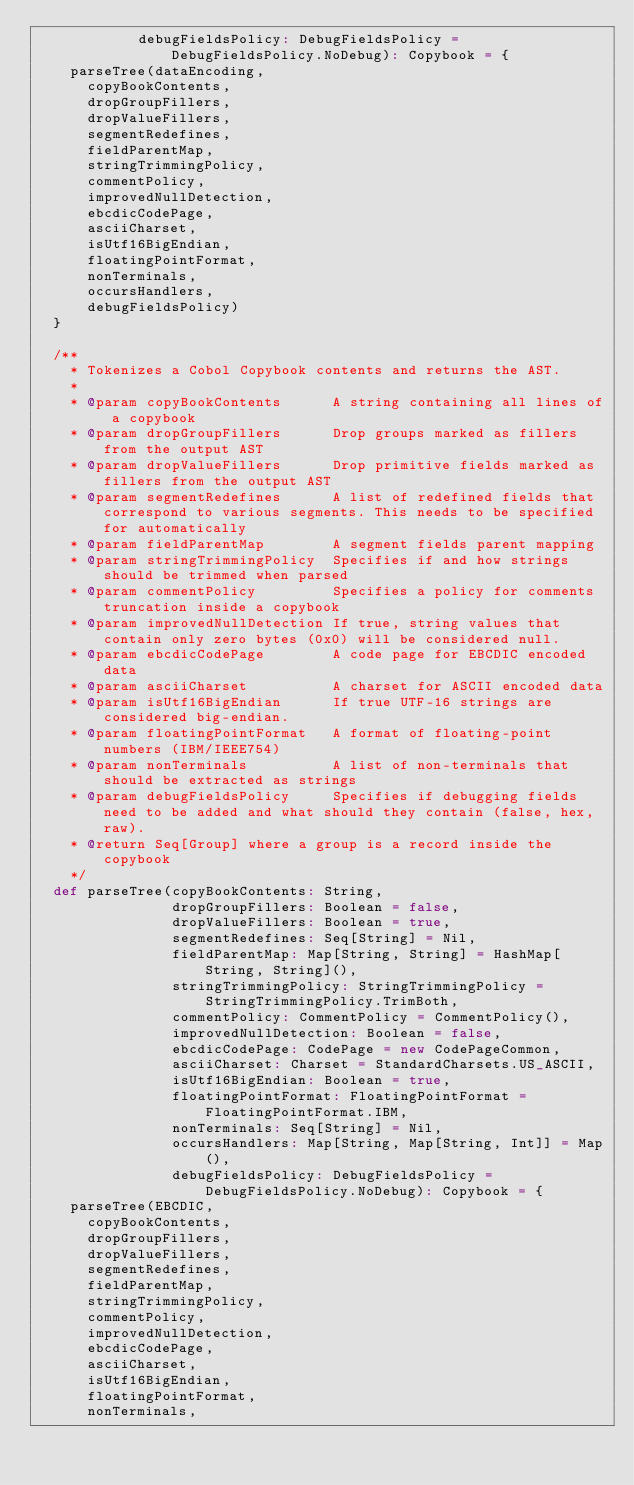<code> <loc_0><loc_0><loc_500><loc_500><_Scala_>            debugFieldsPolicy: DebugFieldsPolicy = DebugFieldsPolicy.NoDebug): Copybook = {
    parseTree(dataEncoding,
      copyBookContents,
      dropGroupFillers,
      dropValueFillers,
      segmentRedefines,
      fieldParentMap,
      stringTrimmingPolicy,
      commentPolicy,
      improvedNullDetection,
      ebcdicCodePage,
      asciiCharset,
      isUtf16BigEndian,
      floatingPointFormat,
      nonTerminals,
      occursHandlers,
      debugFieldsPolicy)
  }

  /**
    * Tokenizes a Cobol Copybook contents and returns the AST.
    *
    * @param copyBookContents      A string containing all lines of a copybook
    * @param dropGroupFillers      Drop groups marked as fillers from the output AST
    * @param dropValueFillers      Drop primitive fields marked as fillers from the output AST
    * @param segmentRedefines      A list of redefined fields that correspond to various segments. This needs to be specified for automatically
    * @param fieldParentMap        A segment fields parent mapping
    * @param stringTrimmingPolicy  Specifies if and how strings should be trimmed when parsed
    * @param commentPolicy         Specifies a policy for comments truncation inside a copybook
    * @param improvedNullDetection If true, string values that contain only zero bytes (0x0) will be considered null.
    * @param ebcdicCodePage        A code page for EBCDIC encoded data
    * @param asciiCharset          A charset for ASCII encoded data
    * @param isUtf16BigEndian      If true UTF-16 strings are considered big-endian.
    * @param floatingPointFormat   A format of floating-point numbers (IBM/IEEE754)
    * @param nonTerminals          A list of non-terminals that should be extracted as strings
    * @param debugFieldsPolicy     Specifies if debugging fields need to be added and what should they contain (false, hex, raw).
    * @return Seq[Group] where a group is a record inside the copybook
    */
  def parseTree(copyBookContents: String,
                dropGroupFillers: Boolean = false,
                dropValueFillers: Boolean = true,
                segmentRedefines: Seq[String] = Nil,
                fieldParentMap: Map[String, String] = HashMap[String, String](),
                stringTrimmingPolicy: StringTrimmingPolicy = StringTrimmingPolicy.TrimBoth,
                commentPolicy: CommentPolicy = CommentPolicy(),
                improvedNullDetection: Boolean = false,
                ebcdicCodePage: CodePage = new CodePageCommon,
                asciiCharset: Charset = StandardCharsets.US_ASCII,
                isUtf16BigEndian: Boolean = true,
                floatingPointFormat: FloatingPointFormat = FloatingPointFormat.IBM,
                nonTerminals: Seq[String] = Nil,
                occursHandlers: Map[String, Map[String, Int]] = Map(),
                debugFieldsPolicy: DebugFieldsPolicy = DebugFieldsPolicy.NoDebug): Copybook = {
    parseTree(EBCDIC,
      copyBookContents,
      dropGroupFillers,
      dropValueFillers,
      segmentRedefines,
      fieldParentMap,
      stringTrimmingPolicy,
      commentPolicy,
      improvedNullDetection,
      ebcdicCodePage,
      asciiCharset,
      isUtf16BigEndian,
      floatingPointFormat,
      nonTerminals,</code> 